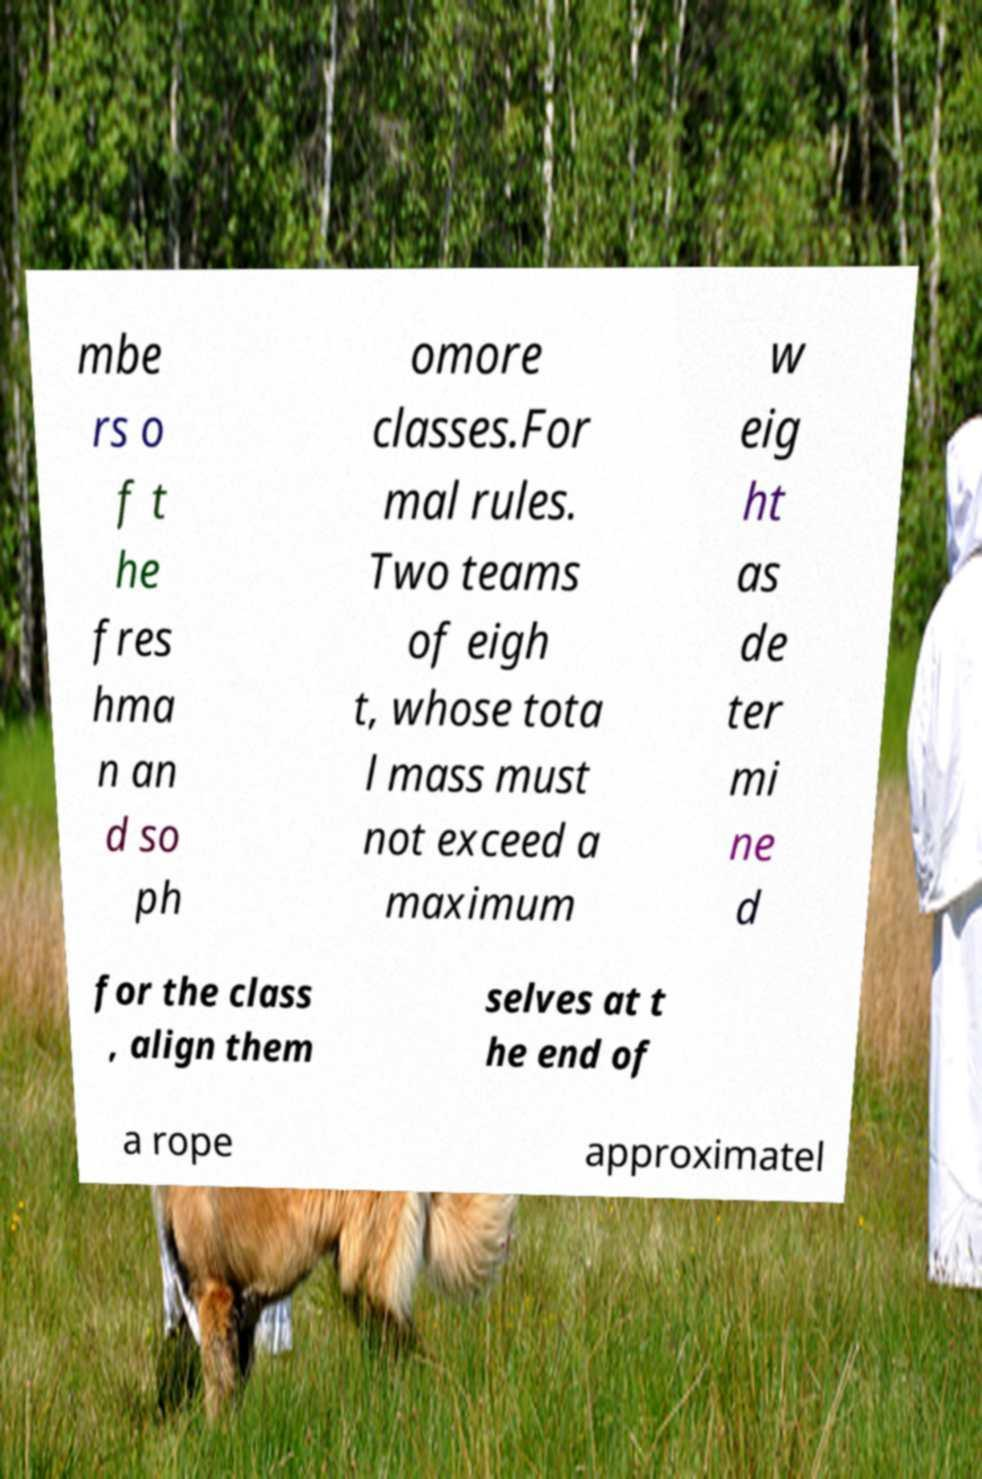Could you extract and type out the text from this image? mbe rs o f t he fres hma n an d so ph omore classes.For mal rules. Two teams of eigh t, whose tota l mass must not exceed a maximum w eig ht as de ter mi ne d for the class , align them selves at t he end of a rope approximatel 